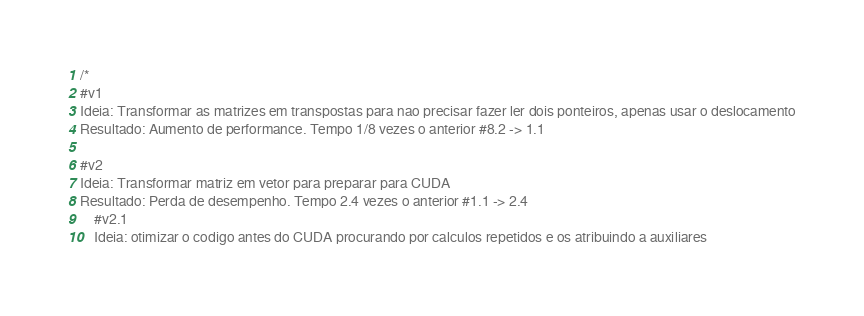<code> <loc_0><loc_0><loc_500><loc_500><_Cuda_>/*
#v1
Ideia: Transformar as matrizes em transpostas para nao precisar fazer ler dois ponteiros, apenas usar o deslocamento
Resultado: Aumento de performance. Tempo 1/8 vezes o anterior #8.2 -> 1.1

#v2
Ideia: Transformar matriz em vetor para preparar para CUDA
Resultado: Perda de desempenho. Tempo 2.4 vezes o anterior #1.1 -> 2.4
	#v2.1
	Ideia: otimizar o codigo antes do CUDA procurando por calculos repetidos e os atribuindo a auxiliares</code> 